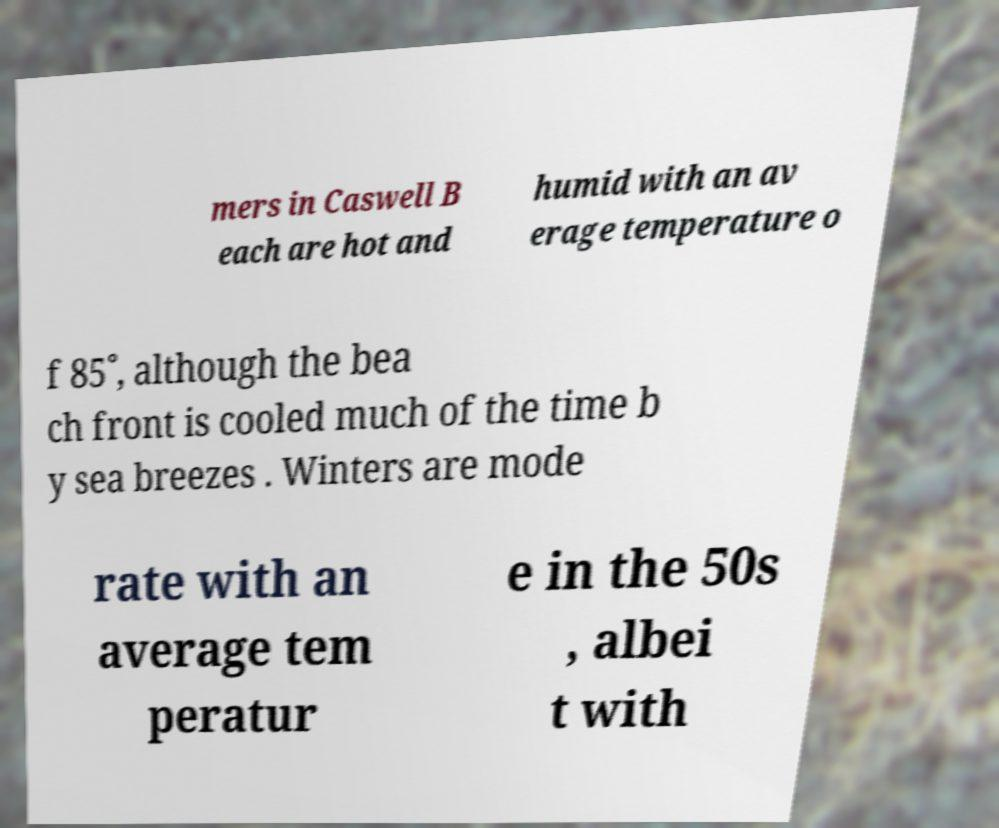Could you extract and type out the text from this image? mers in Caswell B each are hot and humid with an av erage temperature o f 85˚, although the bea ch front is cooled much of the time b y sea breezes . Winters are mode rate with an average tem peratur e in the 50s , albei t with 